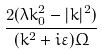<formula> <loc_0><loc_0><loc_500><loc_500>\frac { 2 ( \lambda k _ { 0 } ^ { 2 } - | k | ^ { 2 } ) } { ( k ^ { 2 } + i \varepsilon ) \Omega }</formula> 